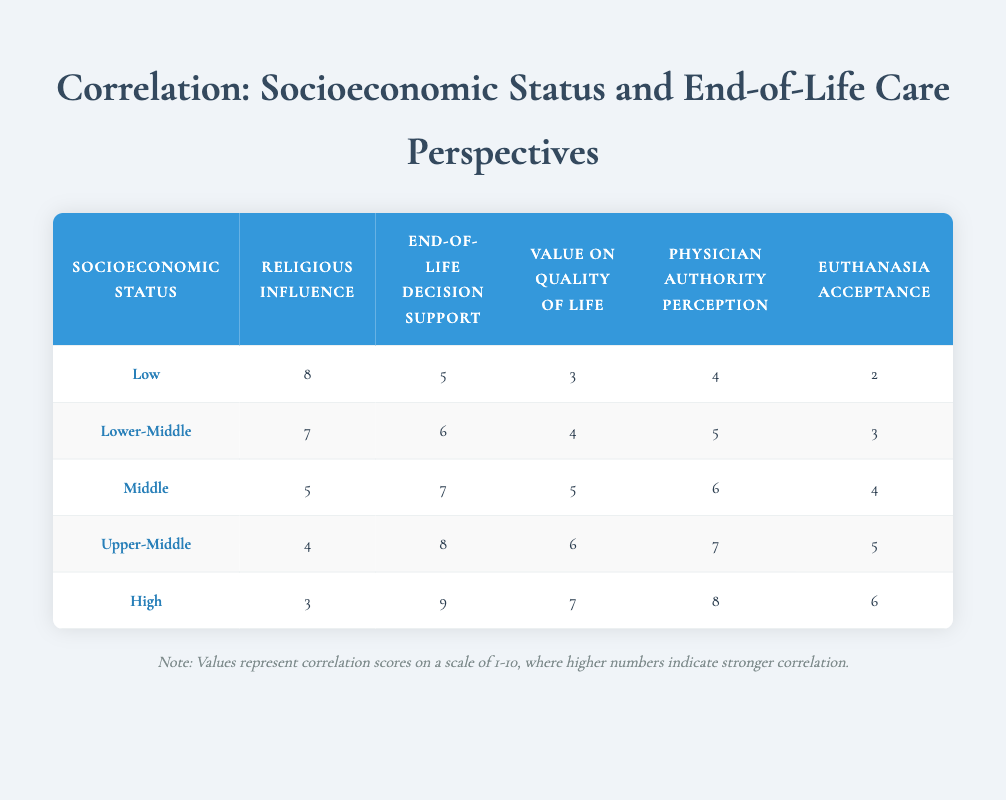What is the religious influence score for the High socioeconomic status group? According to the table, the religious influence score for the High socioeconomic status group is listed directly in the table under the relevant column. The score is 3.
Answer: 3 Which socioeconomic status group has the highest acceptance of euthanasia? The table shows the acceptance of euthanasia for each socioeconomic status group. By comparing the values in the last column, the High group has the highest acceptance score of 6.
Answer: High What is the difference in end-of-life decision making support between the Low and Upper-Middle socioeconomic groups? The end-of-life decision making support score for the Low group is 5, while for the Upper-Middle group it is 8. The difference is calculated as 8 - 5 = 3.
Answer: 3 Is the perception of physician authority higher in the Middle or Lower-Middle socioeconomic status group? The perception of physician authority for the Middle group is 6 and for the Lower-Middle group is 5. Therefore, the Middle group has a higher perception score.
Answer: Yes What is the average value on quality of life across all socioeconomic status groups? To find the average, we sum the quality of life scores (3 + 4 + 5 + 6 + 7 = 25) and divide by the number of groups (5). So, 25 / 5 = 5.
Answer: 5 Which socioeconomic status group shows a decrease in the religious influence score as the socioeconomic status increases? The religious influence scores drop from Low (8) to High (3) systematically across all groups. This indicates a consistent decrease.
Answer: Yes What is the total score for end-of-life decision making support in Low and Middle socioeconomic status groups combined? The end-of-life decision making scores are 5 (Low) and 7 (Middle). Adding these together gives a total score of 5 + 7 = 12.
Answer: 12 Does a higher socioeconomic status correlate with higher values placed on quality of life? By observing the quality of life scores from the Low group (3) to the High group (7), there is an increase, indicating a positive correlation with higher socioeconomic status.
Answer: Yes What is the median perception of physician authority among all socioeconomic status groups? To find the median, we first list the scores in order: 4, 5, 6, 7, 8. The middle score in a set of five data points is 6, making that the median.
Answer: 6 